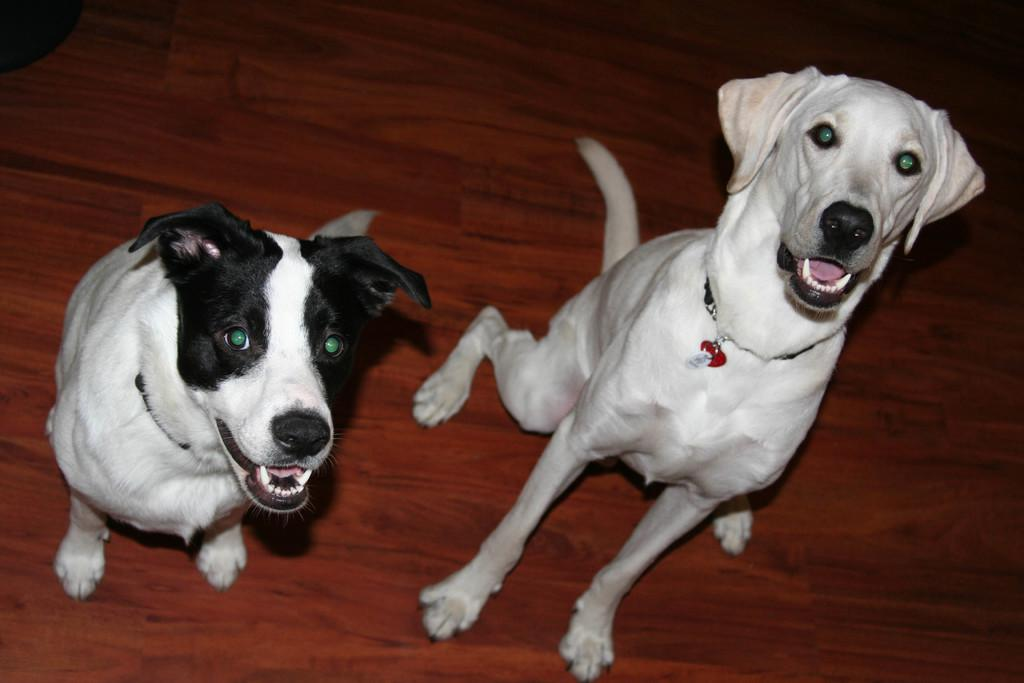How many dogs are present in the image? There are two dogs in the image. What type of surface are the dogs on? The dogs are on a wooden surface. What type of mark can be seen on the farmer's shirt in the image? There is no farmer present in the image, so there is no shirt or mark to observe. 